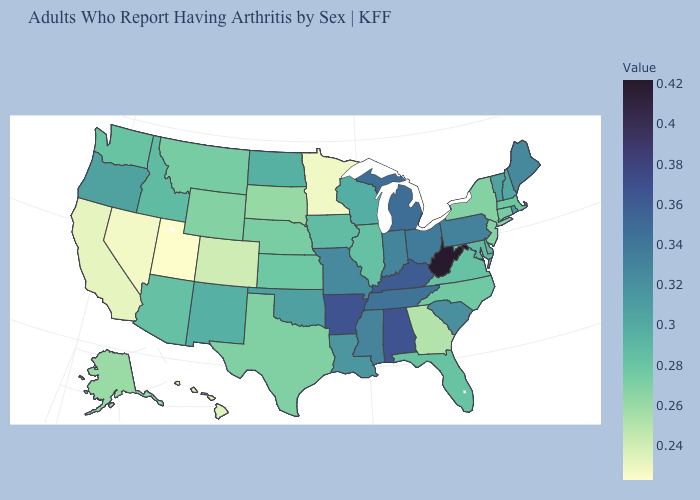Among the states that border Arizona , does New Mexico have the highest value?
Write a very short answer. Yes. Among the states that border Pennsylvania , does West Virginia have the highest value?
Answer briefly. Yes. Does the map have missing data?
Answer briefly. No. Does Utah have the lowest value in the USA?
Give a very brief answer. Yes. Does West Virginia have the highest value in the USA?
Keep it brief. Yes. Does Ohio have a lower value than Kansas?
Give a very brief answer. No. Does New Jersey have a higher value than Mississippi?
Short answer required. No. Among the states that border Iowa , does Missouri have the highest value?
Keep it brief. Yes. Among the states that border Mississippi , which have the highest value?
Write a very short answer. Alabama, Arkansas. 